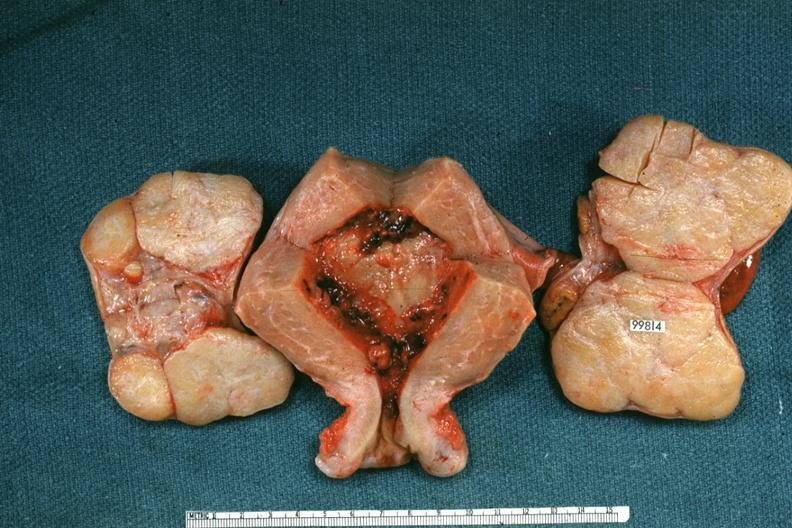how does this image show uterus and ovaries?
Answer the question using a single word or phrase. With bilateral brenner tumors 